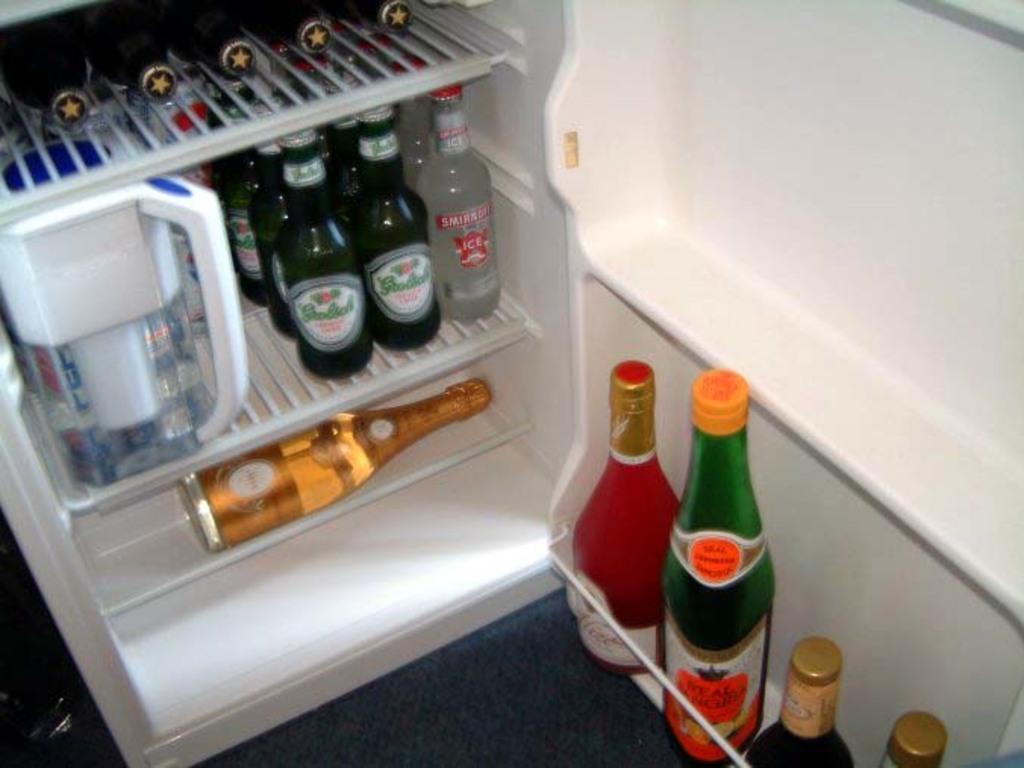How would you summarize this image in a sentence or two? This image is taken indoors. At the bottom of the image there is a floor. In the middle of the image there is a fridge which is opened. There are many bottles in the fridge and there is a jar. On the right side of the image there are four bottles. 